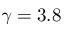Convert formula to latex. <formula><loc_0><loc_0><loc_500><loc_500>\gamma = 3 . 8</formula> 